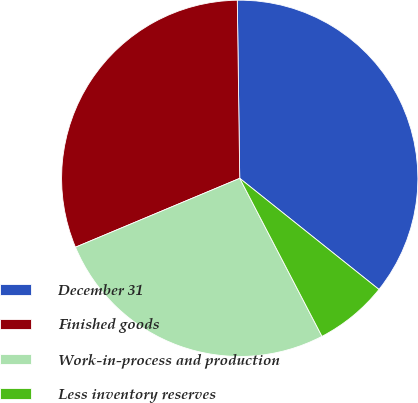Convert chart. <chart><loc_0><loc_0><loc_500><loc_500><pie_chart><fcel>December 31<fcel>Finished goods<fcel>Work-in-process and production<fcel>Less inventory reserves<nl><fcel>35.94%<fcel>31.1%<fcel>26.32%<fcel>6.64%<nl></chart> 